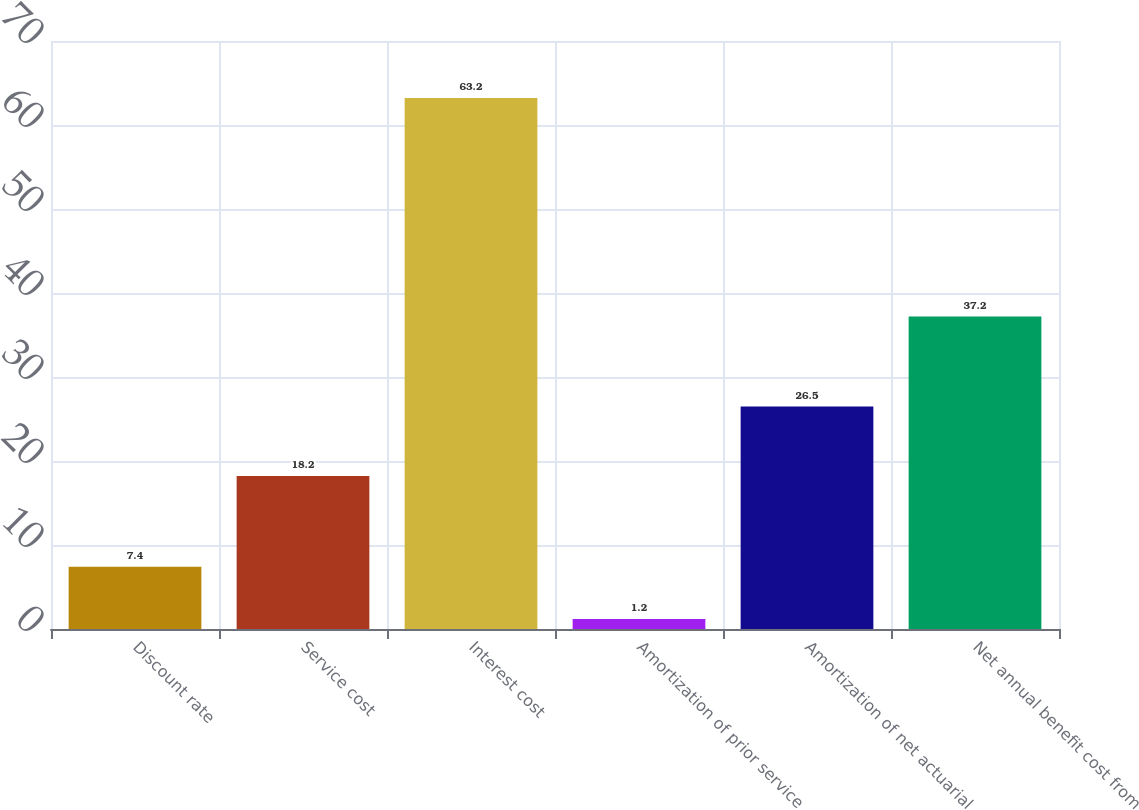<chart> <loc_0><loc_0><loc_500><loc_500><bar_chart><fcel>Discount rate<fcel>Service cost<fcel>Interest cost<fcel>Amortization of prior service<fcel>Amortization of net actuarial<fcel>Net annual benefit cost from<nl><fcel>7.4<fcel>18.2<fcel>63.2<fcel>1.2<fcel>26.5<fcel>37.2<nl></chart> 